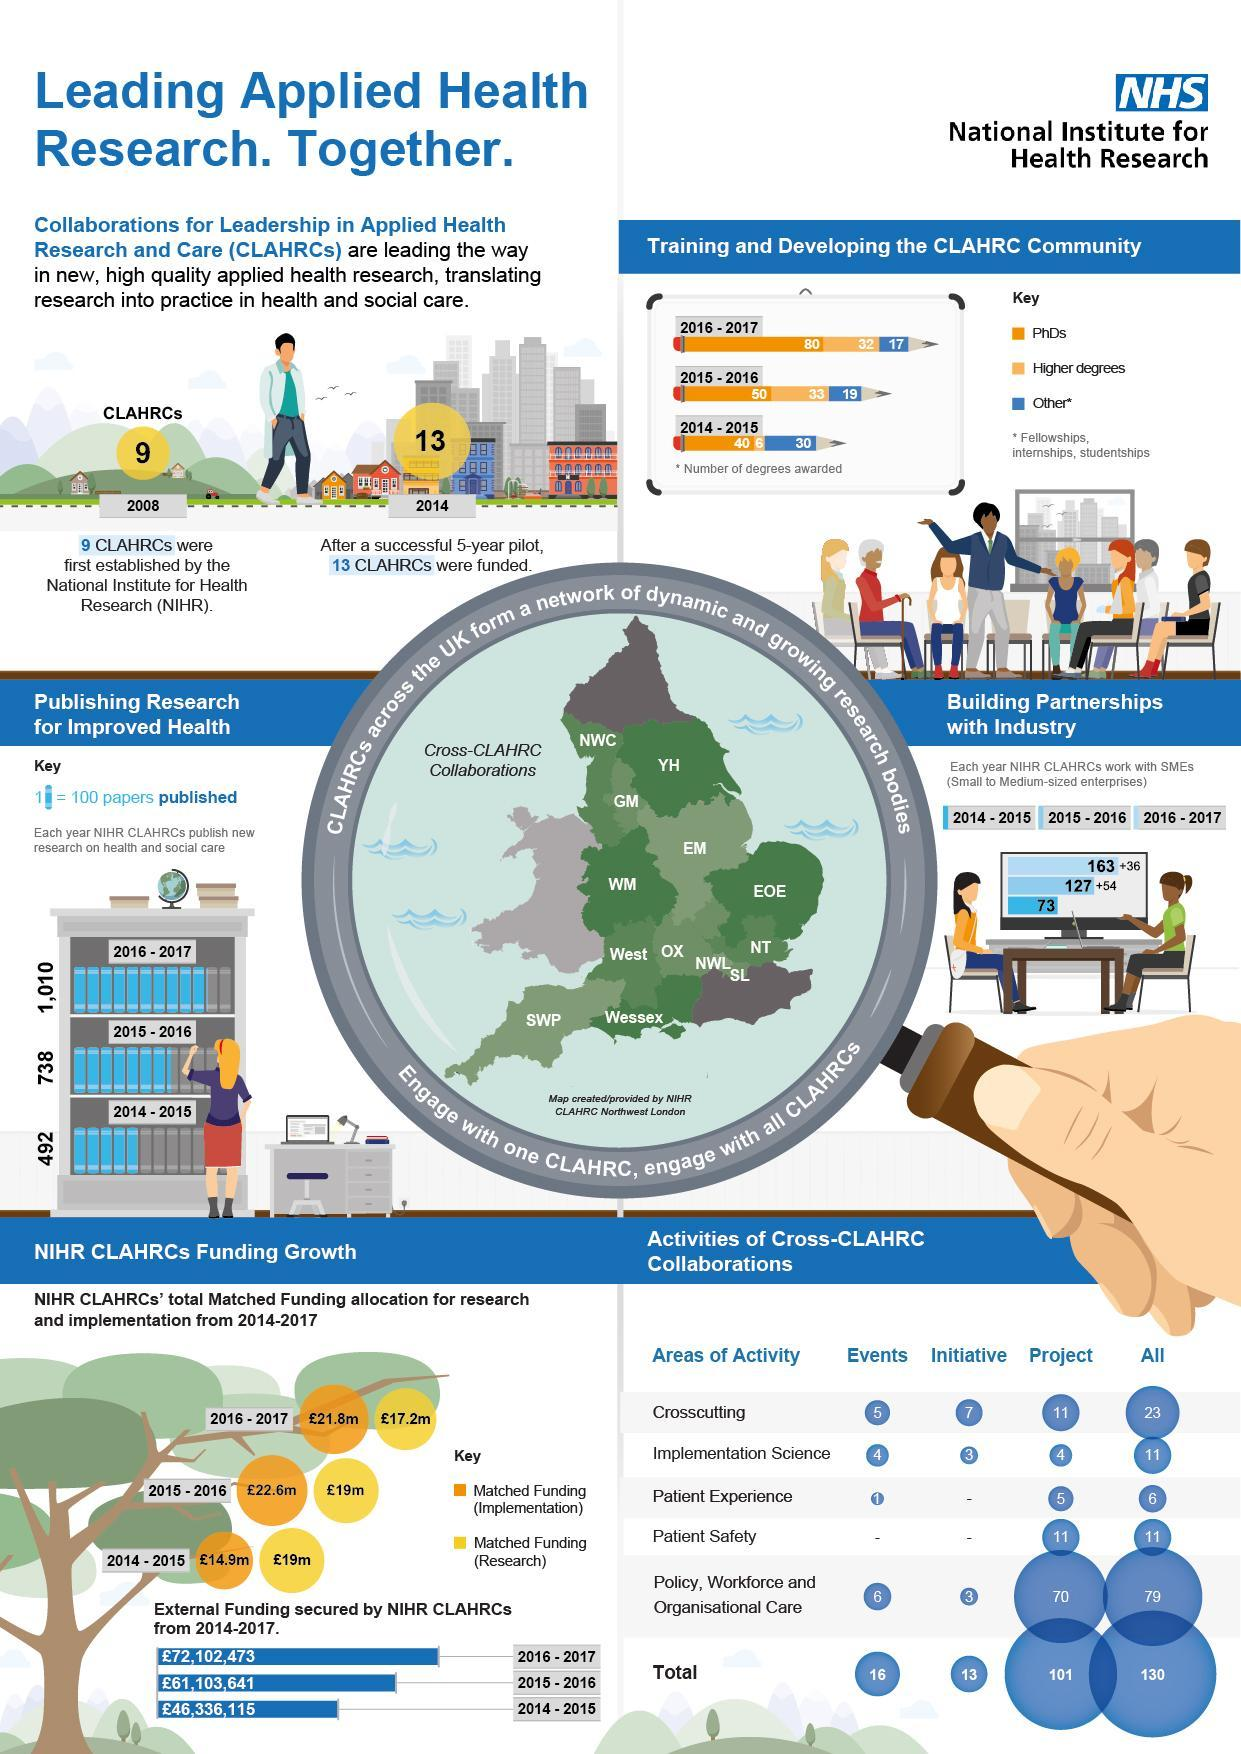How many papers of research on health and social care were published in 2014-2015?
Answer the question with a short phrase. 492 How many papers of research on health and social care were published in 2016-2017? 1,010 Which degree was awarded the second most in 2015-2016? Higher degrees What is the total external funding secured by NIHR CLAHRCs from 2014-2017? £179,542,229 How many more CLAHRCs have been established by NIHR by 2014 after 9 were established in 2008? 4 Which degree was awarded the most in 2015-2016? PhDs Which degree was awarded the most in 2014-2015? PhDs How many papers of research on health and social care were published in 2015-2016? 738 How many higher degrees were awarded during 2014-2015? 6 How many PhDs were awarded in the year 2016-2017? 80 